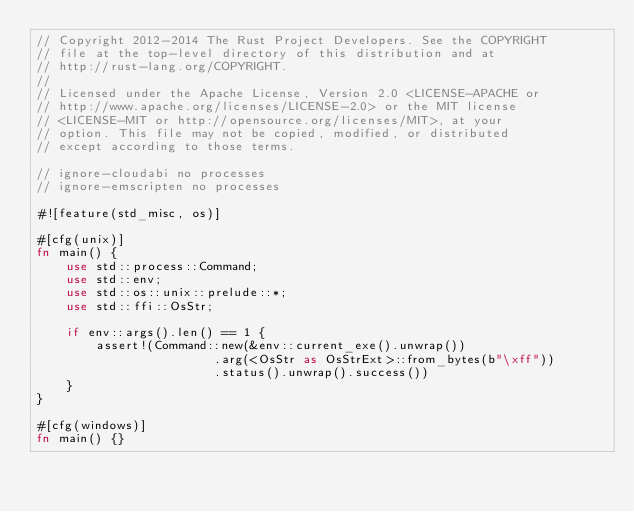Convert code to text. <code><loc_0><loc_0><loc_500><loc_500><_Rust_>// Copyright 2012-2014 The Rust Project Developers. See the COPYRIGHT
// file at the top-level directory of this distribution and at
// http://rust-lang.org/COPYRIGHT.
//
// Licensed under the Apache License, Version 2.0 <LICENSE-APACHE or
// http://www.apache.org/licenses/LICENSE-2.0> or the MIT license
// <LICENSE-MIT or http://opensource.org/licenses/MIT>, at your
// option. This file may not be copied, modified, or distributed
// except according to those terms.

// ignore-cloudabi no processes
// ignore-emscripten no processes

#![feature(std_misc, os)]

#[cfg(unix)]
fn main() {
    use std::process::Command;
    use std::env;
    use std::os::unix::prelude::*;
    use std::ffi::OsStr;

    if env::args().len() == 1 {
        assert!(Command::new(&env::current_exe().unwrap())
                        .arg(<OsStr as OsStrExt>::from_bytes(b"\xff"))
                        .status().unwrap().success())
    }
}

#[cfg(windows)]
fn main() {}
</code> 